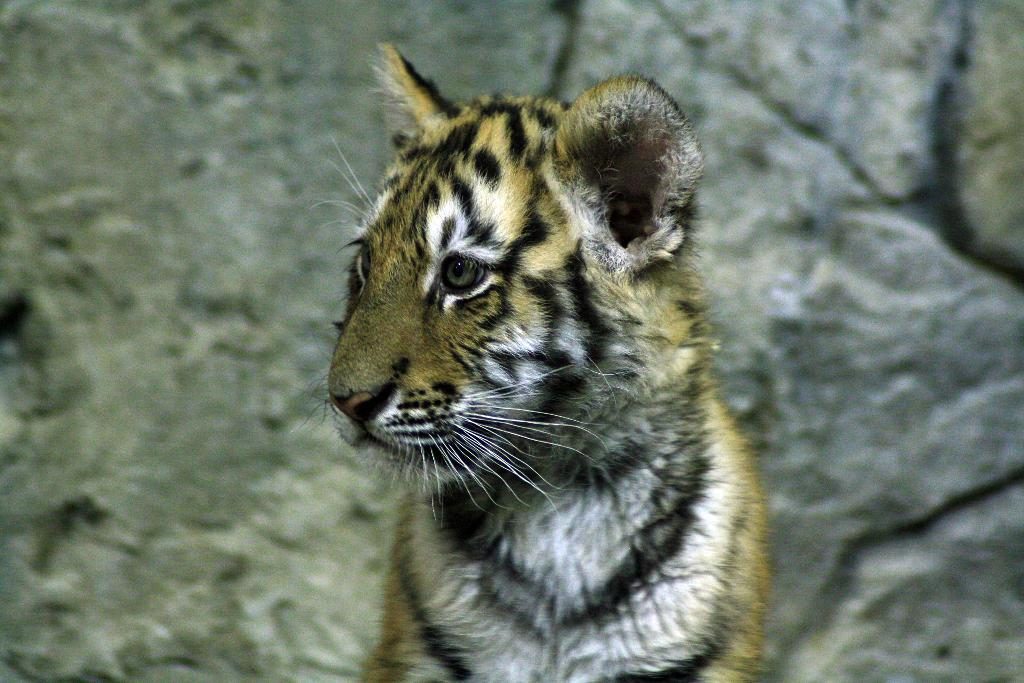What type of animal is in the image? There is a tiger in the image. What is the tiger standing in front of? The tiger is in front of a rocky wall. How does the tiger use magic to clean the dust off its fur in the image? There is no indication of magic or dust in the image; it simply features a tiger standing in front of a rocky wall. 